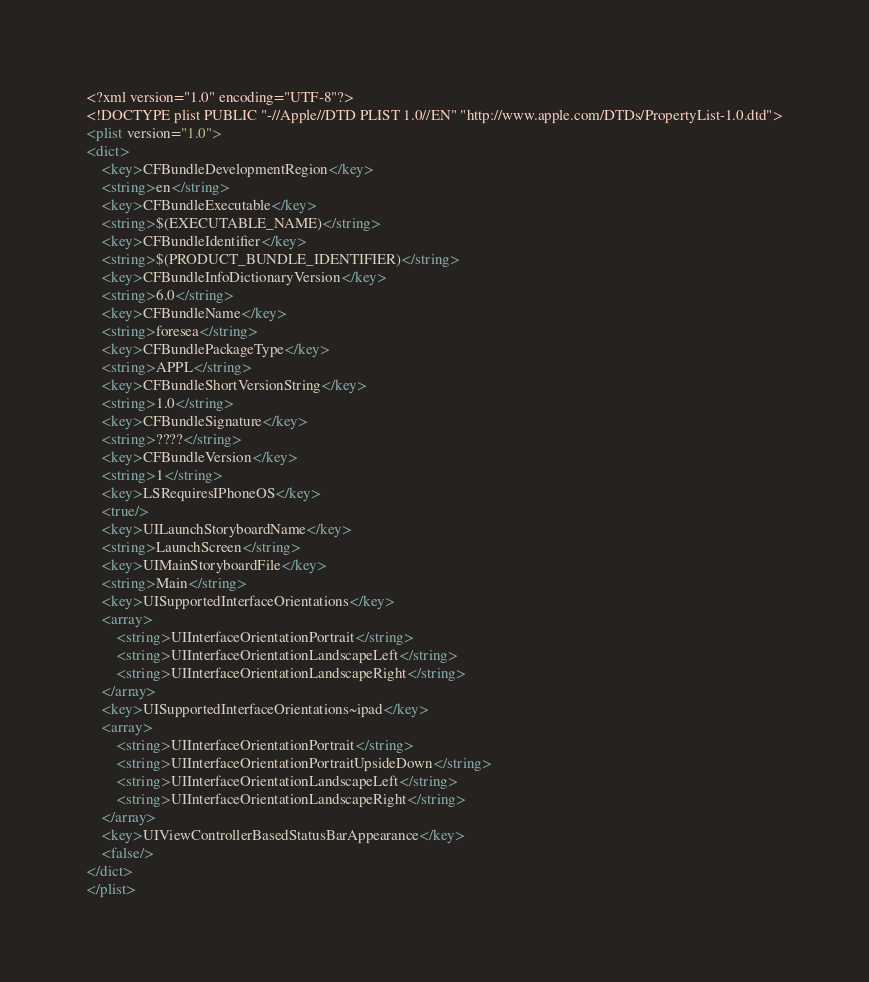<code> <loc_0><loc_0><loc_500><loc_500><_XML_><?xml version="1.0" encoding="UTF-8"?>
<!DOCTYPE plist PUBLIC "-//Apple//DTD PLIST 1.0//EN" "http://www.apple.com/DTDs/PropertyList-1.0.dtd">
<plist version="1.0">
<dict>
	<key>CFBundleDevelopmentRegion</key>
	<string>en</string>
	<key>CFBundleExecutable</key>
	<string>$(EXECUTABLE_NAME)</string>
	<key>CFBundleIdentifier</key>
	<string>$(PRODUCT_BUNDLE_IDENTIFIER)</string>
	<key>CFBundleInfoDictionaryVersion</key>
	<string>6.0</string>
	<key>CFBundleName</key>
	<string>foresea</string>
	<key>CFBundlePackageType</key>
	<string>APPL</string>
	<key>CFBundleShortVersionString</key>
	<string>1.0</string>
	<key>CFBundleSignature</key>
	<string>????</string>
	<key>CFBundleVersion</key>
	<string>1</string>
	<key>LSRequiresIPhoneOS</key>
	<true/>
	<key>UILaunchStoryboardName</key>
	<string>LaunchScreen</string>
	<key>UIMainStoryboardFile</key>
	<string>Main</string>
	<key>UISupportedInterfaceOrientations</key>
	<array>
		<string>UIInterfaceOrientationPortrait</string>
		<string>UIInterfaceOrientationLandscapeLeft</string>
		<string>UIInterfaceOrientationLandscapeRight</string>
	</array>
	<key>UISupportedInterfaceOrientations~ipad</key>
	<array>
		<string>UIInterfaceOrientationPortrait</string>
		<string>UIInterfaceOrientationPortraitUpsideDown</string>
		<string>UIInterfaceOrientationLandscapeLeft</string>
		<string>UIInterfaceOrientationLandscapeRight</string>
	</array>
	<key>UIViewControllerBasedStatusBarAppearance</key>
	<false/>
</dict>
</plist>
</code> 